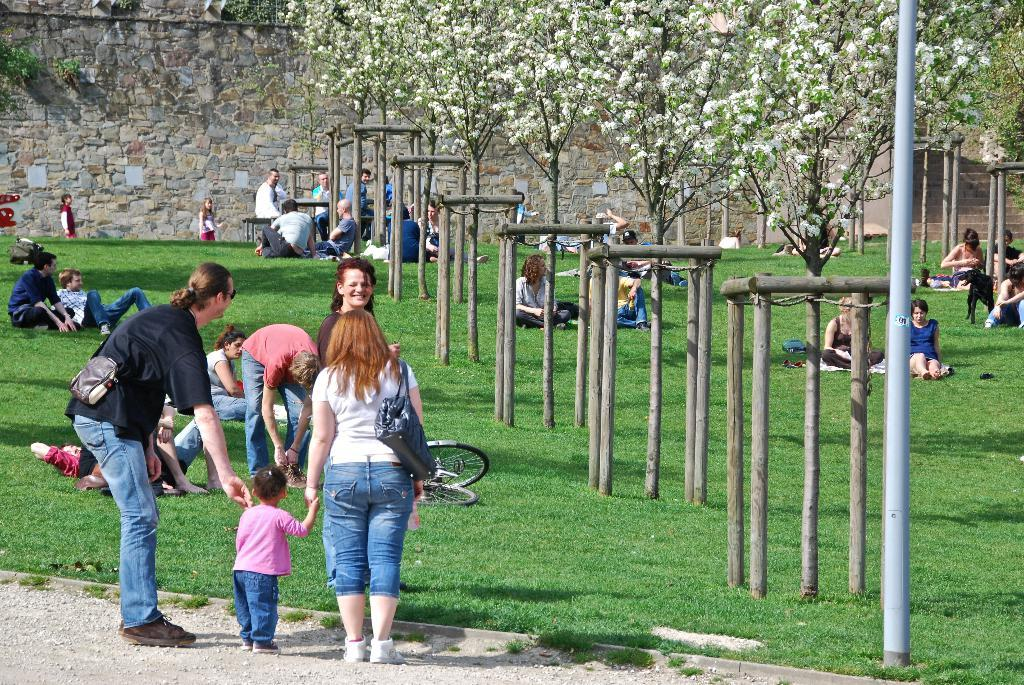How many people are in the image? There is a group of people in the image, but the exact number cannot be determined from the provided facts. What are the people in the image doing? Some people are seated on the grass, and some people are standing. What can be seen in the background of the image? There are trees, flowers, a pole, and a bicycle in the background of the image. How many apples are being picked by the writer in the image? There is no writer or apples present in the image. What type of club is being used by the people in the image? There is no club visible in the image. 